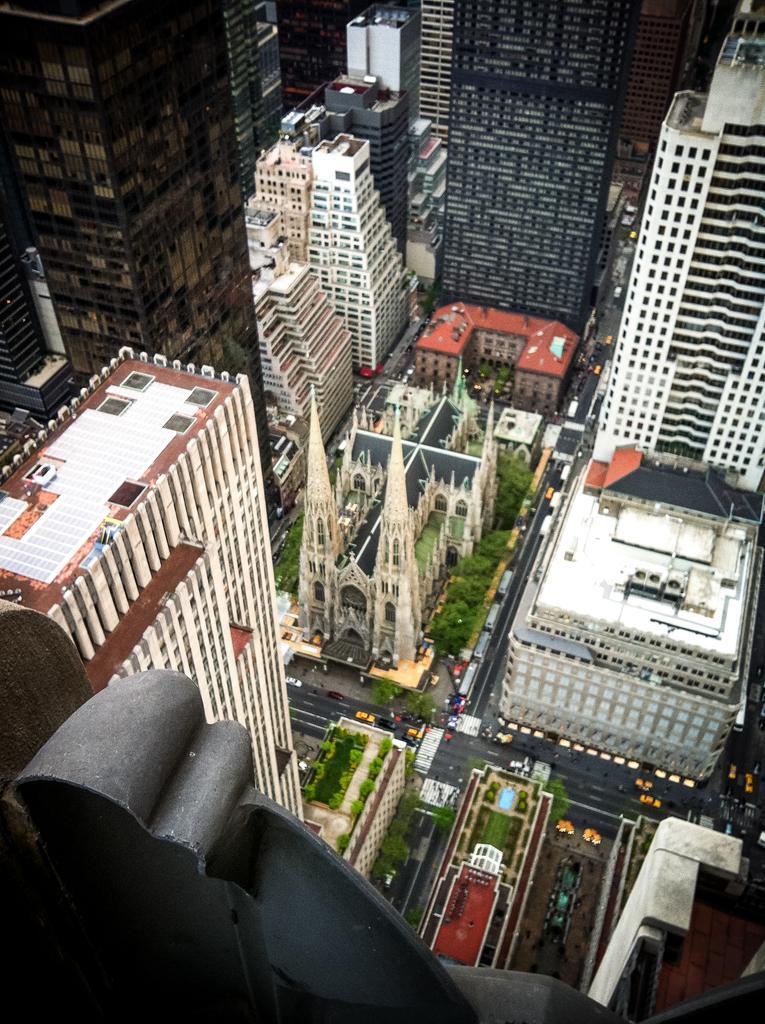Could you give a brief overview of what you see in this image? In this image we can see a top view of a street. There are many buildings, trees, roads and vehicles. 